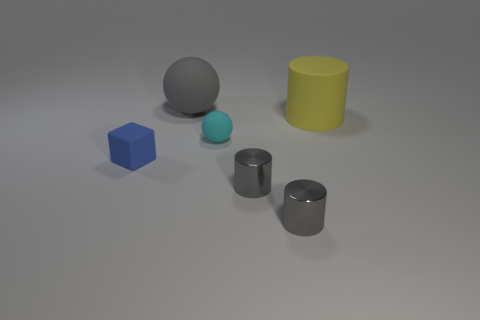How many gray cylinders must be subtracted to get 1 gray cylinders? 1 Add 2 yellow rubber things. How many objects exist? 8 Subtract all small gray metal cylinders. How many cylinders are left? 1 Subtract all purple balls. How many gray cylinders are left? 2 Subtract 1 balls. How many balls are left? 1 Subtract all shiny things. Subtract all big rubber objects. How many objects are left? 2 Add 4 rubber cubes. How many rubber cubes are left? 5 Add 2 red matte cylinders. How many red matte cylinders exist? 2 Subtract all cyan spheres. How many spheres are left? 1 Subtract 1 cyan balls. How many objects are left? 5 